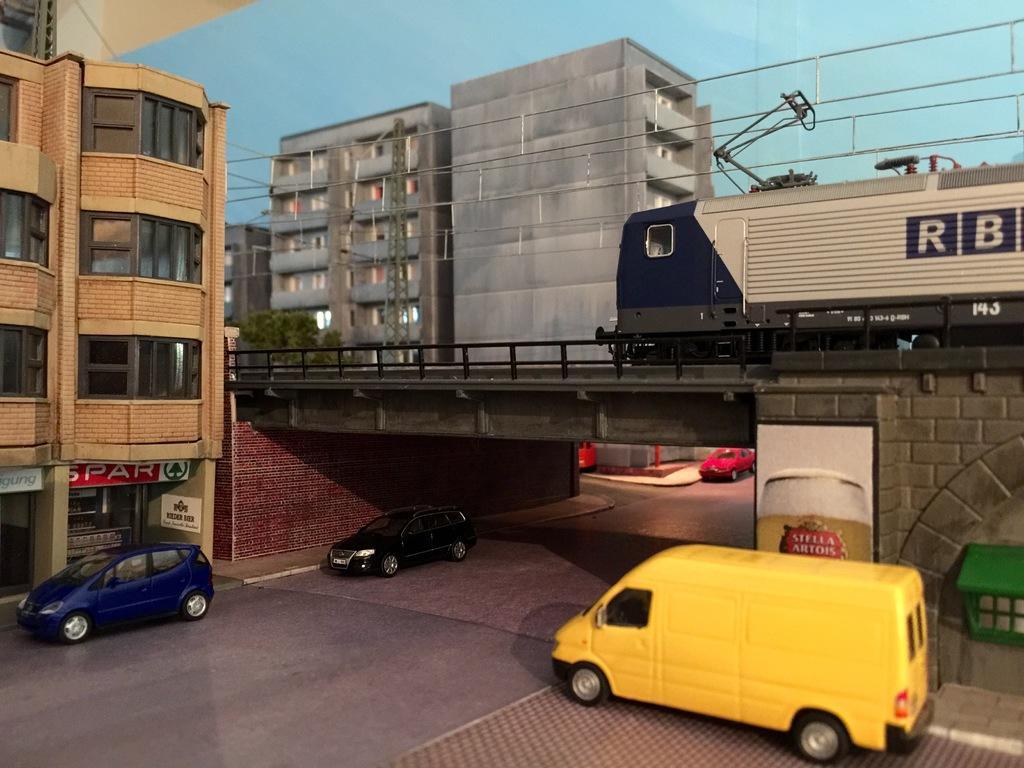Could you give a brief overview of what you see in this image? In this image we can see some vehicles on the road. We can also see some buildings with windows, a tower with wires, plants, a train on the bridge and the sky which looks cloudy. 